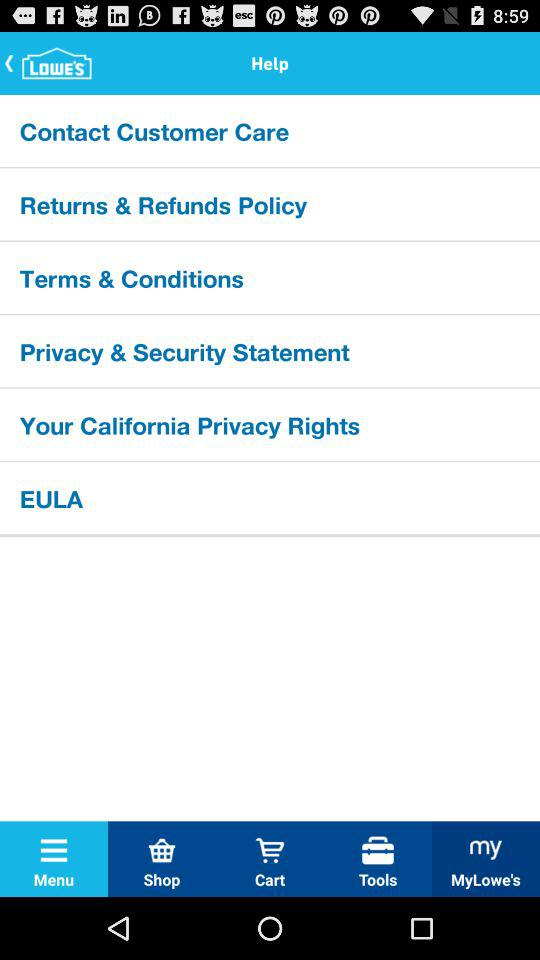Which tab is selected? The selected tab is menu. 